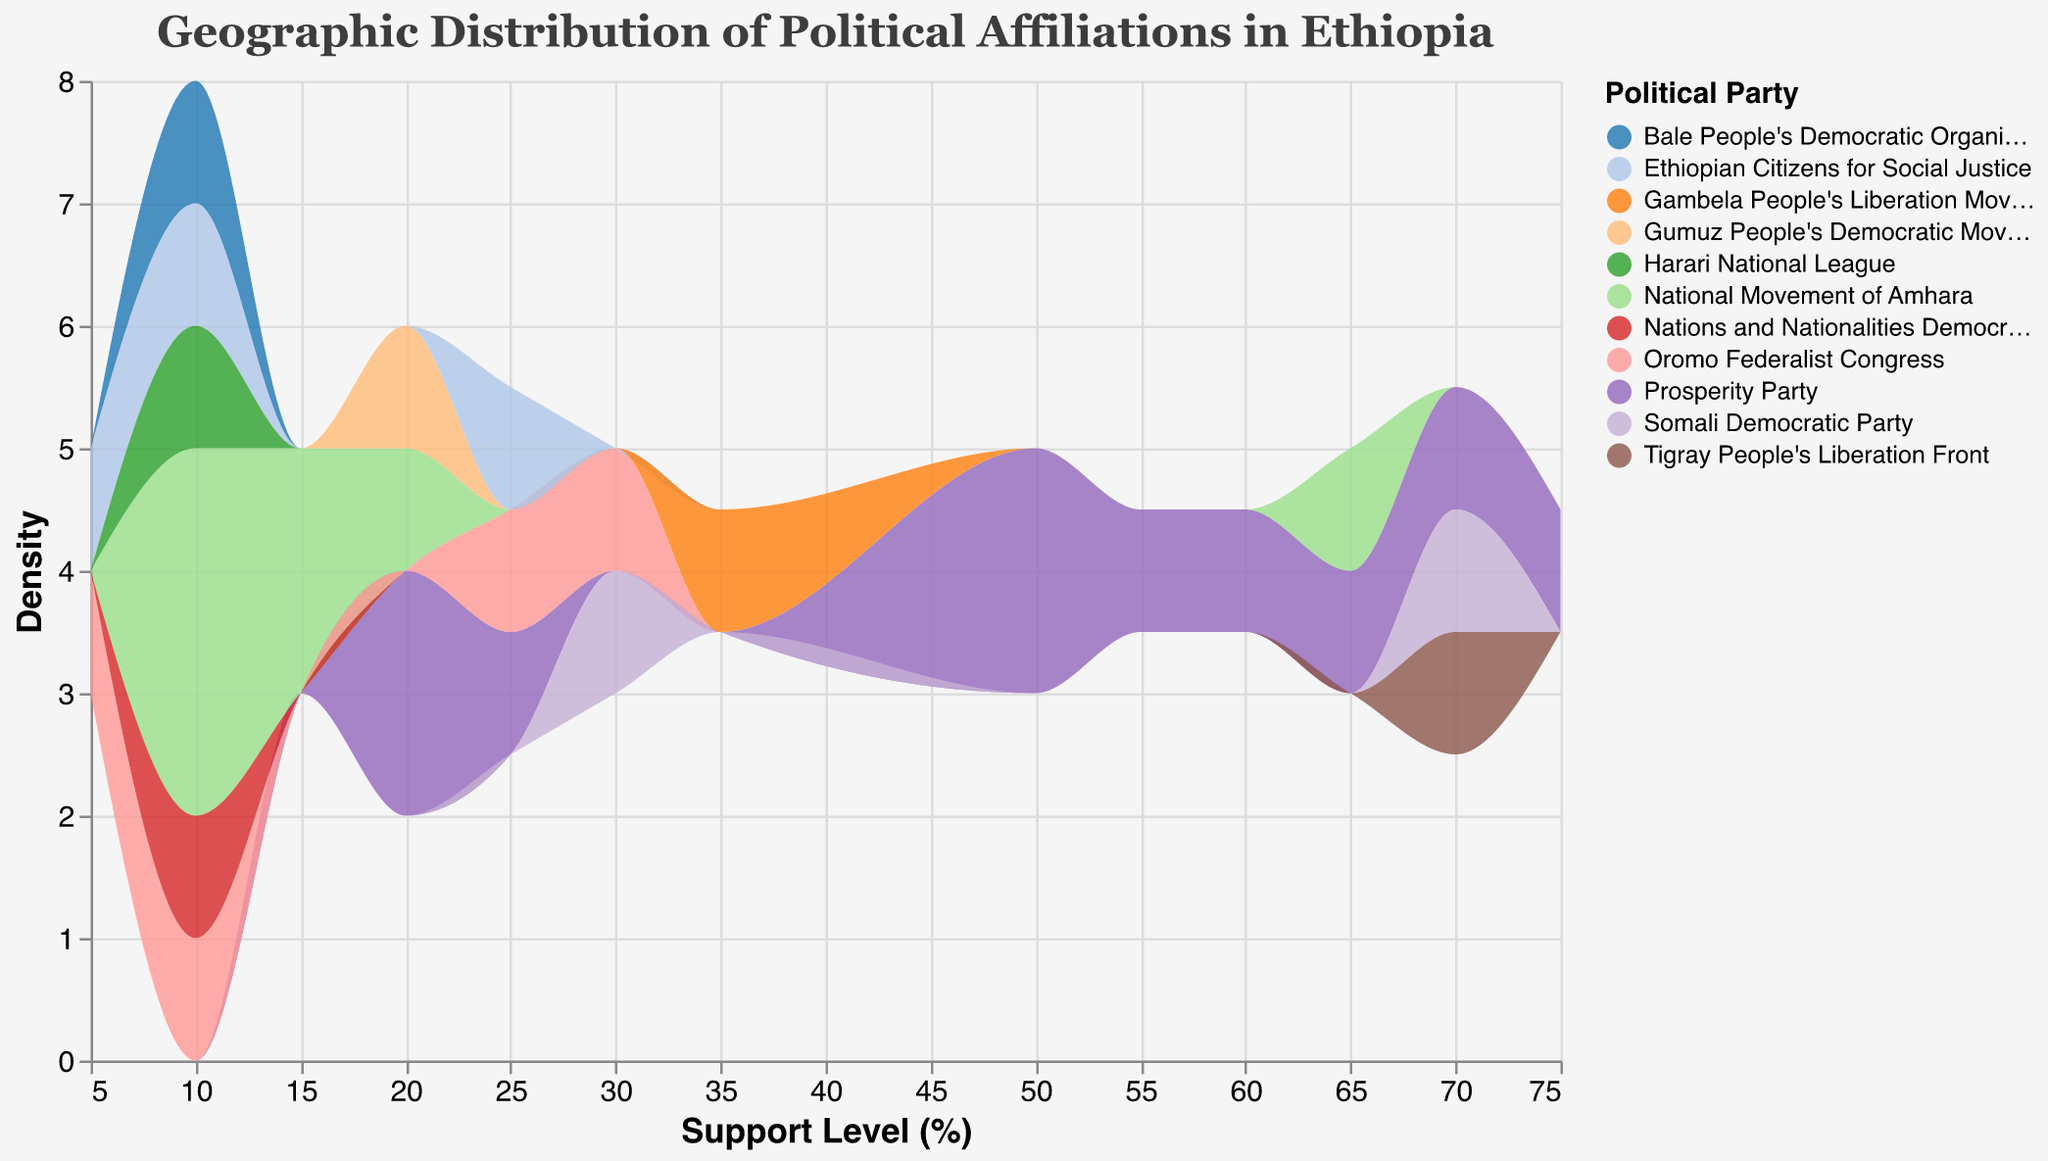What is the title of the plot? The title of the plot is clearly stated at the top of the figure.
Answer: Geographic Distribution of Political Affiliations in Ethiopia Which political party has the highest density of support across all regions? By looking at the areas under the density curves, the political party with the largest area would have the highest density of support.
Answer: Prosperity Party What support level has the highest density for the National Movement of Amhara? Examine the density curve's peak for the National Movement of Amhara's color. The peak indicates the support level with the highest density.
Answer: 10% and 65% How does the support level of the Oromo Federalist Congress in Addis Ababa compare to Oromia? Look at the support levels listed for the Oromo Federalist Congress in both regions and compare them.
Answer: Higher in Oromia Among the regions with data, which has the highest support level for the Prosperity Party? Look for the highest support level value for the Prosperity Party across different regions.
Answer: Addis Ababa (75%) Summarize the support levels of political parties in the Somali region. Identify the support levels for political parties in the Somali region from the data.
Answer: Somali Democratic Party (70%), Prosperity Party (20%), Ethiopian Citizens for Social Justice (10%) Which two political parties have the closest support levels in the Afar region? Identify the support levels of political parties in Afar and determine which two are closest.
Answer: Somali Democratic Party (30%) and National Movement of Amhara (20%) Compare the density of support levels between the Prosperity Party and the Ethiopian Citizens for Social Justice in Dire Dawa. Examine the density curves for these two parties in Dire Dawa.
Answer: Prosperity Party has higher density How does the support level distribution for the Gambela People's Liberation Movement compare to the Harari National League? Compare their respective density curves.
Answer: Gambela People's Liberation Movement has higher support What party has the majority support in the Tigray region? Identify the party with the highest percentage in Tigray from the data listing.
Answer: Tigray People's Liberation Front (70%) 